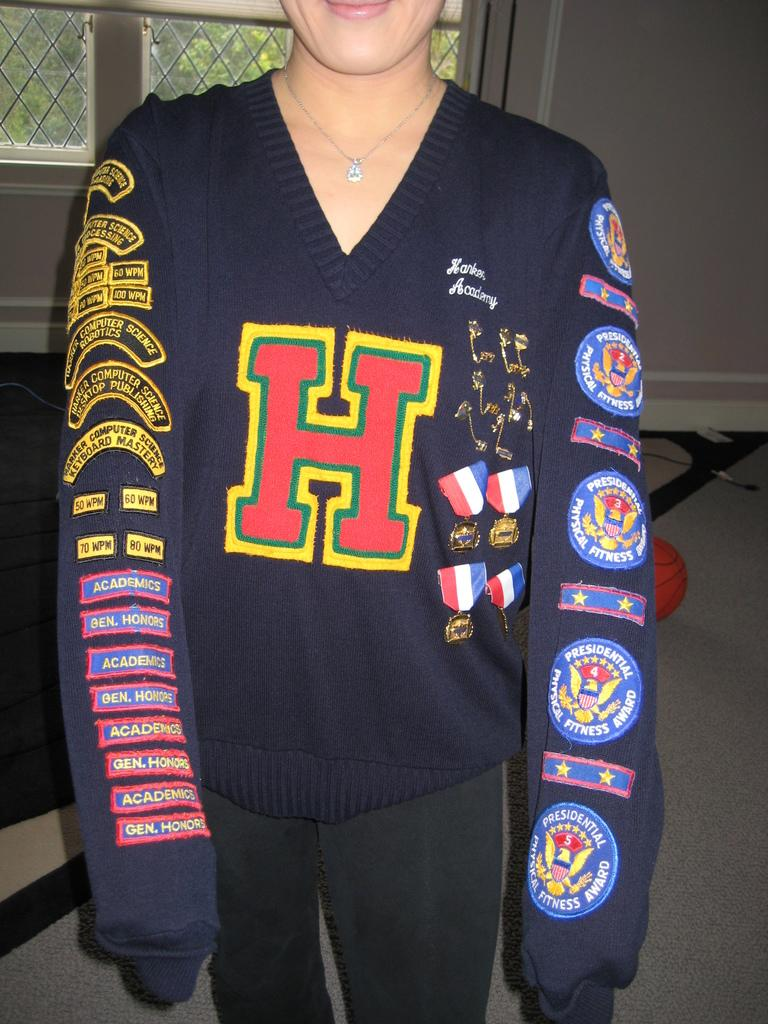<image>
Describe the image concisely. the lady is wearing a sweater with letter H in the front 